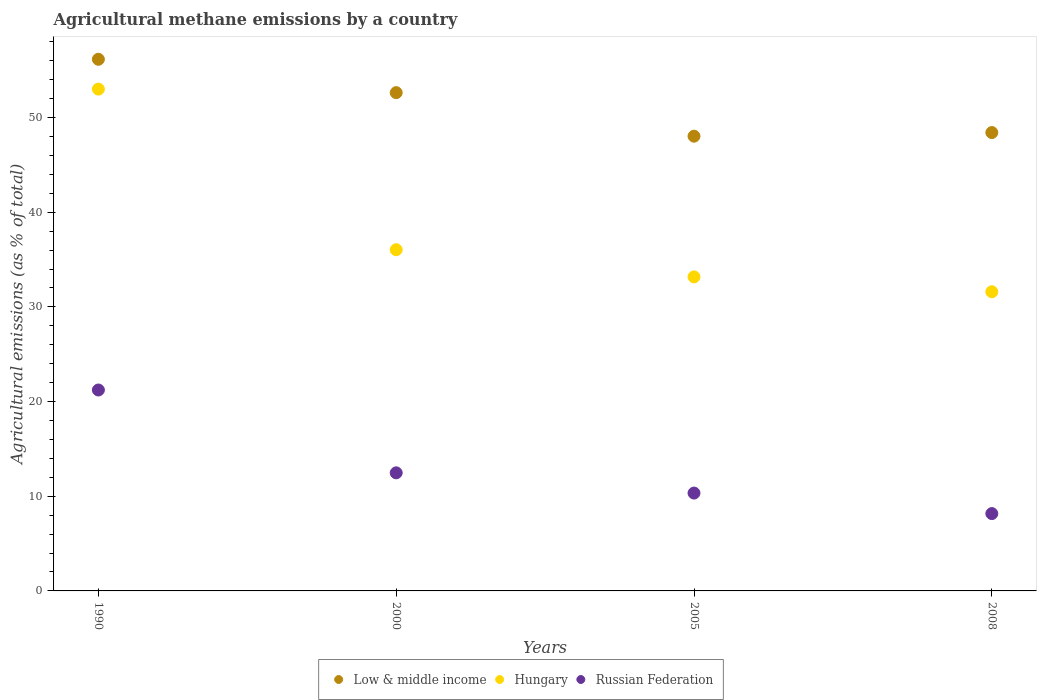Is the number of dotlines equal to the number of legend labels?
Provide a short and direct response. Yes. What is the amount of agricultural methane emitted in Low & middle income in 2008?
Your answer should be compact. 48.42. Across all years, what is the maximum amount of agricultural methane emitted in Hungary?
Your answer should be very brief. 53.01. Across all years, what is the minimum amount of agricultural methane emitted in Hungary?
Offer a terse response. 31.6. In which year was the amount of agricultural methane emitted in Low & middle income minimum?
Your answer should be compact. 2005. What is the total amount of agricultural methane emitted in Low & middle income in the graph?
Your response must be concise. 205.25. What is the difference between the amount of agricultural methane emitted in Low & middle income in 1990 and that in 2008?
Keep it short and to the point. 7.74. What is the difference between the amount of agricultural methane emitted in Russian Federation in 2000 and the amount of agricultural methane emitted in Hungary in 1990?
Offer a terse response. -40.53. What is the average amount of agricultural methane emitted in Russian Federation per year?
Offer a terse response. 13.05. In the year 1990, what is the difference between the amount of agricultural methane emitted in Low & middle income and amount of agricultural methane emitted in Russian Federation?
Provide a succinct answer. 34.93. What is the ratio of the amount of agricultural methane emitted in Low & middle income in 2000 to that in 2005?
Keep it short and to the point. 1.1. Is the amount of agricultural methane emitted in Hungary in 1990 less than that in 2008?
Your answer should be compact. No. Is the difference between the amount of agricultural methane emitted in Low & middle income in 1990 and 2005 greater than the difference between the amount of agricultural methane emitted in Russian Federation in 1990 and 2005?
Your answer should be very brief. No. What is the difference between the highest and the second highest amount of agricultural methane emitted in Low & middle income?
Offer a very short reply. 3.52. What is the difference between the highest and the lowest amount of agricultural methane emitted in Low & middle income?
Your response must be concise. 8.12. Does the amount of agricultural methane emitted in Hungary monotonically increase over the years?
Make the answer very short. No. Where does the legend appear in the graph?
Ensure brevity in your answer.  Bottom center. How many legend labels are there?
Provide a short and direct response. 3. What is the title of the graph?
Your answer should be very brief. Agricultural methane emissions by a country. Does "United Kingdom" appear as one of the legend labels in the graph?
Make the answer very short. No. What is the label or title of the X-axis?
Make the answer very short. Years. What is the label or title of the Y-axis?
Provide a succinct answer. Agricultural emissions (as % of total). What is the Agricultural emissions (as % of total) in Low & middle income in 1990?
Offer a terse response. 56.16. What is the Agricultural emissions (as % of total) in Hungary in 1990?
Give a very brief answer. 53.01. What is the Agricultural emissions (as % of total) in Russian Federation in 1990?
Provide a succinct answer. 21.22. What is the Agricultural emissions (as % of total) in Low & middle income in 2000?
Provide a succinct answer. 52.63. What is the Agricultural emissions (as % of total) of Hungary in 2000?
Your answer should be very brief. 36.04. What is the Agricultural emissions (as % of total) of Russian Federation in 2000?
Offer a very short reply. 12.47. What is the Agricultural emissions (as % of total) of Low & middle income in 2005?
Ensure brevity in your answer.  48.04. What is the Agricultural emissions (as % of total) in Hungary in 2005?
Offer a terse response. 33.17. What is the Agricultural emissions (as % of total) in Russian Federation in 2005?
Ensure brevity in your answer.  10.34. What is the Agricultural emissions (as % of total) of Low & middle income in 2008?
Your answer should be compact. 48.42. What is the Agricultural emissions (as % of total) in Hungary in 2008?
Provide a succinct answer. 31.6. What is the Agricultural emissions (as % of total) in Russian Federation in 2008?
Offer a very short reply. 8.17. Across all years, what is the maximum Agricultural emissions (as % of total) in Low & middle income?
Keep it short and to the point. 56.16. Across all years, what is the maximum Agricultural emissions (as % of total) of Hungary?
Keep it short and to the point. 53.01. Across all years, what is the maximum Agricultural emissions (as % of total) in Russian Federation?
Your answer should be very brief. 21.22. Across all years, what is the minimum Agricultural emissions (as % of total) in Low & middle income?
Offer a very short reply. 48.04. Across all years, what is the minimum Agricultural emissions (as % of total) of Hungary?
Give a very brief answer. 31.6. Across all years, what is the minimum Agricultural emissions (as % of total) of Russian Federation?
Ensure brevity in your answer.  8.17. What is the total Agricultural emissions (as % of total) of Low & middle income in the graph?
Your answer should be very brief. 205.25. What is the total Agricultural emissions (as % of total) in Hungary in the graph?
Provide a succinct answer. 153.83. What is the total Agricultural emissions (as % of total) in Russian Federation in the graph?
Your response must be concise. 52.2. What is the difference between the Agricultural emissions (as % of total) in Low & middle income in 1990 and that in 2000?
Offer a terse response. 3.52. What is the difference between the Agricultural emissions (as % of total) in Hungary in 1990 and that in 2000?
Provide a succinct answer. 16.96. What is the difference between the Agricultural emissions (as % of total) of Russian Federation in 1990 and that in 2000?
Offer a terse response. 8.75. What is the difference between the Agricultural emissions (as % of total) of Low & middle income in 1990 and that in 2005?
Provide a succinct answer. 8.12. What is the difference between the Agricultural emissions (as % of total) of Hungary in 1990 and that in 2005?
Your answer should be very brief. 19.84. What is the difference between the Agricultural emissions (as % of total) of Russian Federation in 1990 and that in 2005?
Ensure brevity in your answer.  10.89. What is the difference between the Agricultural emissions (as % of total) of Low & middle income in 1990 and that in 2008?
Your answer should be compact. 7.74. What is the difference between the Agricultural emissions (as % of total) in Hungary in 1990 and that in 2008?
Make the answer very short. 21.41. What is the difference between the Agricultural emissions (as % of total) in Russian Federation in 1990 and that in 2008?
Make the answer very short. 13.06. What is the difference between the Agricultural emissions (as % of total) in Low & middle income in 2000 and that in 2005?
Ensure brevity in your answer.  4.6. What is the difference between the Agricultural emissions (as % of total) in Hungary in 2000 and that in 2005?
Ensure brevity in your answer.  2.87. What is the difference between the Agricultural emissions (as % of total) of Russian Federation in 2000 and that in 2005?
Offer a very short reply. 2.14. What is the difference between the Agricultural emissions (as % of total) in Low & middle income in 2000 and that in 2008?
Make the answer very short. 4.22. What is the difference between the Agricultural emissions (as % of total) in Hungary in 2000 and that in 2008?
Keep it short and to the point. 4.44. What is the difference between the Agricultural emissions (as % of total) of Russian Federation in 2000 and that in 2008?
Ensure brevity in your answer.  4.31. What is the difference between the Agricultural emissions (as % of total) of Low & middle income in 2005 and that in 2008?
Your response must be concise. -0.38. What is the difference between the Agricultural emissions (as % of total) in Hungary in 2005 and that in 2008?
Provide a succinct answer. 1.57. What is the difference between the Agricultural emissions (as % of total) of Russian Federation in 2005 and that in 2008?
Offer a terse response. 2.17. What is the difference between the Agricultural emissions (as % of total) in Low & middle income in 1990 and the Agricultural emissions (as % of total) in Hungary in 2000?
Make the answer very short. 20.12. What is the difference between the Agricultural emissions (as % of total) in Low & middle income in 1990 and the Agricultural emissions (as % of total) in Russian Federation in 2000?
Your response must be concise. 43.68. What is the difference between the Agricultural emissions (as % of total) in Hungary in 1990 and the Agricultural emissions (as % of total) in Russian Federation in 2000?
Provide a short and direct response. 40.53. What is the difference between the Agricultural emissions (as % of total) in Low & middle income in 1990 and the Agricultural emissions (as % of total) in Hungary in 2005?
Your answer should be very brief. 22.99. What is the difference between the Agricultural emissions (as % of total) in Low & middle income in 1990 and the Agricultural emissions (as % of total) in Russian Federation in 2005?
Your answer should be compact. 45.82. What is the difference between the Agricultural emissions (as % of total) in Hungary in 1990 and the Agricultural emissions (as % of total) in Russian Federation in 2005?
Make the answer very short. 42.67. What is the difference between the Agricultural emissions (as % of total) of Low & middle income in 1990 and the Agricultural emissions (as % of total) of Hungary in 2008?
Make the answer very short. 24.56. What is the difference between the Agricultural emissions (as % of total) of Low & middle income in 1990 and the Agricultural emissions (as % of total) of Russian Federation in 2008?
Ensure brevity in your answer.  47.99. What is the difference between the Agricultural emissions (as % of total) of Hungary in 1990 and the Agricultural emissions (as % of total) of Russian Federation in 2008?
Keep it short and to the point. 44.84. What is the difference between the Agricultural emissions (as % of total) in Low & middle income in 2000 and the Agricultural emissions (as % of total) in Hungary in 2005?
Ensure brevity in your answer.  19.46. What is the difference between the Agricultural emissions (as % of total) in Low & middle income in 2000 and the Agricultural emissions (as % of total) in Russian Federation in 2005?
Ensure brevity in your answer.  42.3. What is the difference between the Agricultural emissions (as % of total) of Hungary in 2000 and the Agricultural emissions (as % of total) of Russian Federation in 2005?
Provide a succinct answer. 25.71. What is the difference between the Agricultural emissions (as % of total) in Low & middle income in 2000 and the Agricultural emissions (as % of total) in Hungary in 2008?
Offer a terse response. 21.03. What is the difference between the Agricultural emissions (as % of total) of Low & middle income in 2000 and the Agricultural emissions (as % of total) of Russian Federation in 2008?
Keep it short and to the point. 44.47. What is the difference between the Agricultural emissions (as % of total) in Hungary in 2000 and the Agricultural emissions (as % of total) in Russian Federation in 2008?
Ensure brevity in your answer.  27.87. What is the difference between the Agricultural emissions (as % of total) in Low & middle income in 2005 and the Agricultural emissions (as % of total) in Hungary in 2008?
Your response must be concise. 16.43. What is the difference between the Agricultural emissions (as % of total) in Low & middle income in 2005 and the Agricultural emissions (as % of total) in Russian Federation in 2008?
Make the answer very short. 39.87. What is the difference between the Agricultural emissions (as % of total) in Hungary in 2005 and the Agricultural emissions (as % of total) in Russian Federation in 2008?
Keep it short and to the point. 25. What is the average Agricultural emissions (as % of total) in Low & middle income per year?
Your answer should be very brief. 51.31. What is the average Agricultural emissions (as % of total) in Hungary per year?
Offer a terse response. 38.46. What is the average Agricultural emissions (as % of total) of Russian Federation per year?
Your answer should be compact. 13.05. In the year 1990, what is the difference between the Agricultural emissions (as % of total) in Low & middle income and Agricultural emissions (as % of total) in Hungary?
Offer a terse response. 3.15. In the year 1990, what is the difference between the Agricultural emissions (as % of total) of Low & middle income and Agricultural emissions (as % of total) of Russian Federation?
Your response must be concise. 34.93. In the year 1990, what is the difference between the Agricultural emissions (as % of total) in Hungary and Agricultural emissions (as % of total) in Russian Federation?
Your answer should be compact. 31.78. In the year 2000, what is the difference between the Agricultural emissions (as % of total) of Low & middle income and Agricultural emissions (as % of total) of Hungary?
Offer a very short reply. 16.59. In the year 2000, what is the difference between the Agricultural emissions (as % of total) in Low & middle income and Agricultural emissions (as % of total) in Russian Federation?
Make the answer very short. 40.16. In the year 2000, what is the difference between the Agricultural emissions (as % of total) of Hungary and Agricultural emissions (as % of total) of Russian Federation?
Your answer should be very brief. 23.57. In the year 2005, what is the difference between the Agricultural emissions (as % of total) in Low & middle income and Agricultural emissions (as % of total) in Hungary?
Make the answer very short. 14.86. In the year 2005, what is the difference between the Agricultural emissions (as % of total) of Low & middle income and Agricultural emissions (as % of total) of Russian Federation?
Your answer should be very brief. 37.7. In the year 2005, what is the difference between the Agricultural emissions (as % of total) of Hungary and Agricultural emissions (as % of total) of Russian Federation?
Give a very brief answer. 22.84. In the year 2008, what is the difference between the Agricultural emissions (as % of total) in Low & middle income and Agricultural emissions (as % of total) in Hungary?
Provide a succinct answer. 16.82. In the year 2008, what is the difference between the Agricultural emissions (as % of total) of Low & middle income and Agricultural emissions (as % of total) of Russian Federation?
Provide a succinct answer. 40.25. In the year 2008, what is the difference between the Agricultural emissions (as % of total) of Hungary and Agricultural emissions (as % of total) of Russian Federation?
Keep it short and to the point. 23.43. What is the ratio of the Agricultural emissions (as % of total) of Low & middle income in 1990 to that in 2000?
Keep it short and to the point. 1.07. What is the ratio of the Agricultural emissions (as % of total) in Hungary in 1990 to that in 2000?
Provide a succinct answer. 1.47. What is the ratio of the Agricultural emissions (as % of total) in Russian Federation in 1990 to that in 2000?
Ensure brevity in your answer.  1.7. What is the ratio of the Agricultural emissions (as % of total) in Low & middle income in 1990 to that in 2005?
Your response must be concise. 1.17. What is the ratio of the Agricultural emissions (as % of total) in Hungary in 1990 to that in 2005?
Provide a short and direct response. 1.6. What is the ratio of the Agricultural emissions (as % of total) of Russian Federation in 1990 to that in 2005?
Make the answer very short. 2.05. What is the ratio of the Agricultural emissions (as % of total) in Low & middle income in 1990 to that in 2008?
Provide a short and direct response. 1.16. What is the ratio of the Agricultural emissions (as % of total) of Hungary in 1990 to that in 2008?
Ensure brevity in your answer.  1.68. What is the ratio of the Agricultural emissions (as % of total) of Russian Federation in 1990 to that in 2008?
Your answer should be compact. 2.6. What is the ratio of the Agricultural emissions (as % of total) in Low & middle income in 2000 to that in 2005?
Offer a very short reply. 1.1. What is the ratio of the Agricultural emissions (as % of total) in Hungary in 2000 to that in 2005?
Provide a succinct answer. 1.09. What is the ratio of the Agricultural emissions (as % of total) in Russian Federation in 2000 to that in 2005?
Ensure brevity in your answer.  1.21. What is the ratio of the Agricultural emissions (as % of total) of Low & middle income in 2000 to that in 2008?
Provide a short and direct response. 1.09. What is the ratio of the Agricultural emissions (as % of total) in Hungary in 2000 to that in 2008?
Offer a terse response. 1.14. What is the ratio of the Agricultural emissions (as % of total) in Russian Federation in 2000 to that in 2008?
Provide a succinct answer. 1.53. What is the ratio of the Agricultural emissions (as % of total) in Low & middle income in 2005 to that in 2008?
Your answer should be very brief. 0.99. What is the ratio of the Agricultural emissions (as % of total) in Hungary in 2005 to that in 2008?
Make the answer very short. 1.05. What is the ratio of the Agricultural emissions (as % of total) in Russian Federation in 2005 to that in 2008?
Provide a short and direct response. 1.27. What is the difference between the highest and the second highest Agricultural emissions (as % of total) in Low & middle income?
Offer a terse response. 3.52. What is the difference between the highest and the second highest Agricultural emissions (as % of total) of Hungary?
Offer a very short reply. 16.96. What is the difference between the highest and the second highest Agricultural emissions (as % of total) in Russian Federation?
Give a very brief answer. 8.75. What is the difference between the highest and the lowest Agricultural emissions (as % of total) in Low & middle income?
Your answer should be compact. 8.12. What is the difference between the highest and the lowest Agricultural emissions (as % of total) of Hungary?
Your answer should be very brief. 21.41. What is the difference between the highest and the lowest Agricultural emissions (as % of total) in Russian Federation?
Provide a succinct answer. 13.06. 